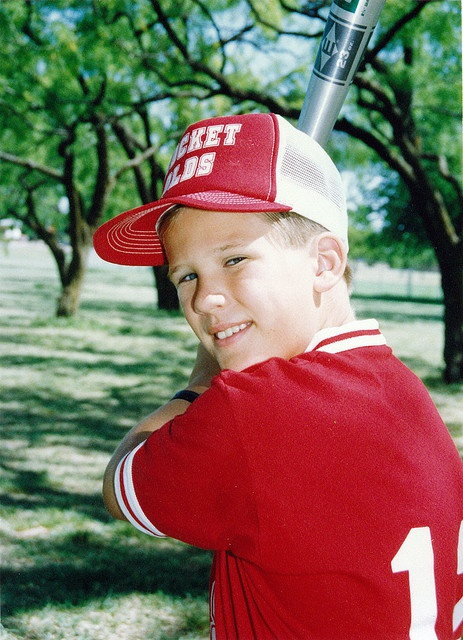Describe the objects in this image and their specific colors. I can see people in green, brown, white, and tan tones and baseball bat in green, gray, darkgray, lightgray, and teal tones in this image. 